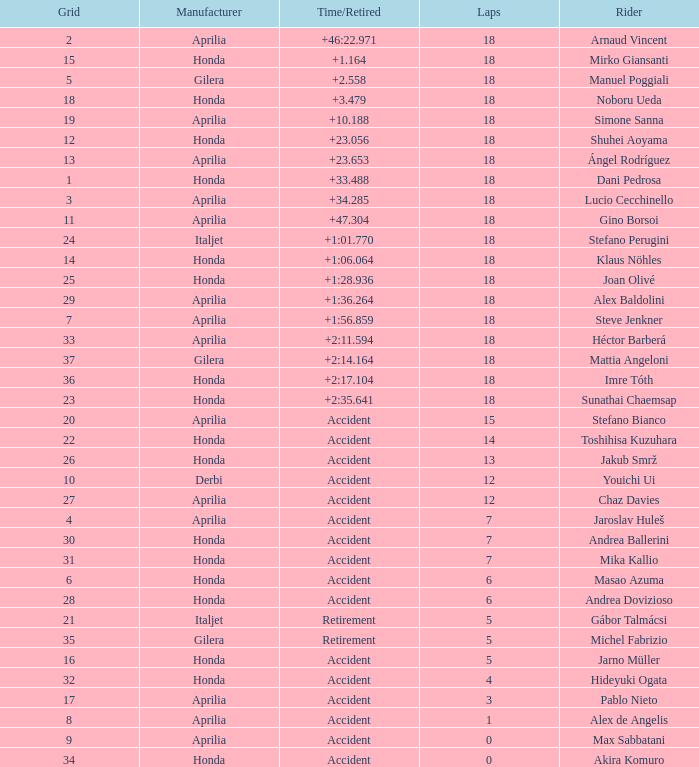What is the average number of laps with an accident time/retired, aprilia manufacturer and a grid of 27? 12.0. 